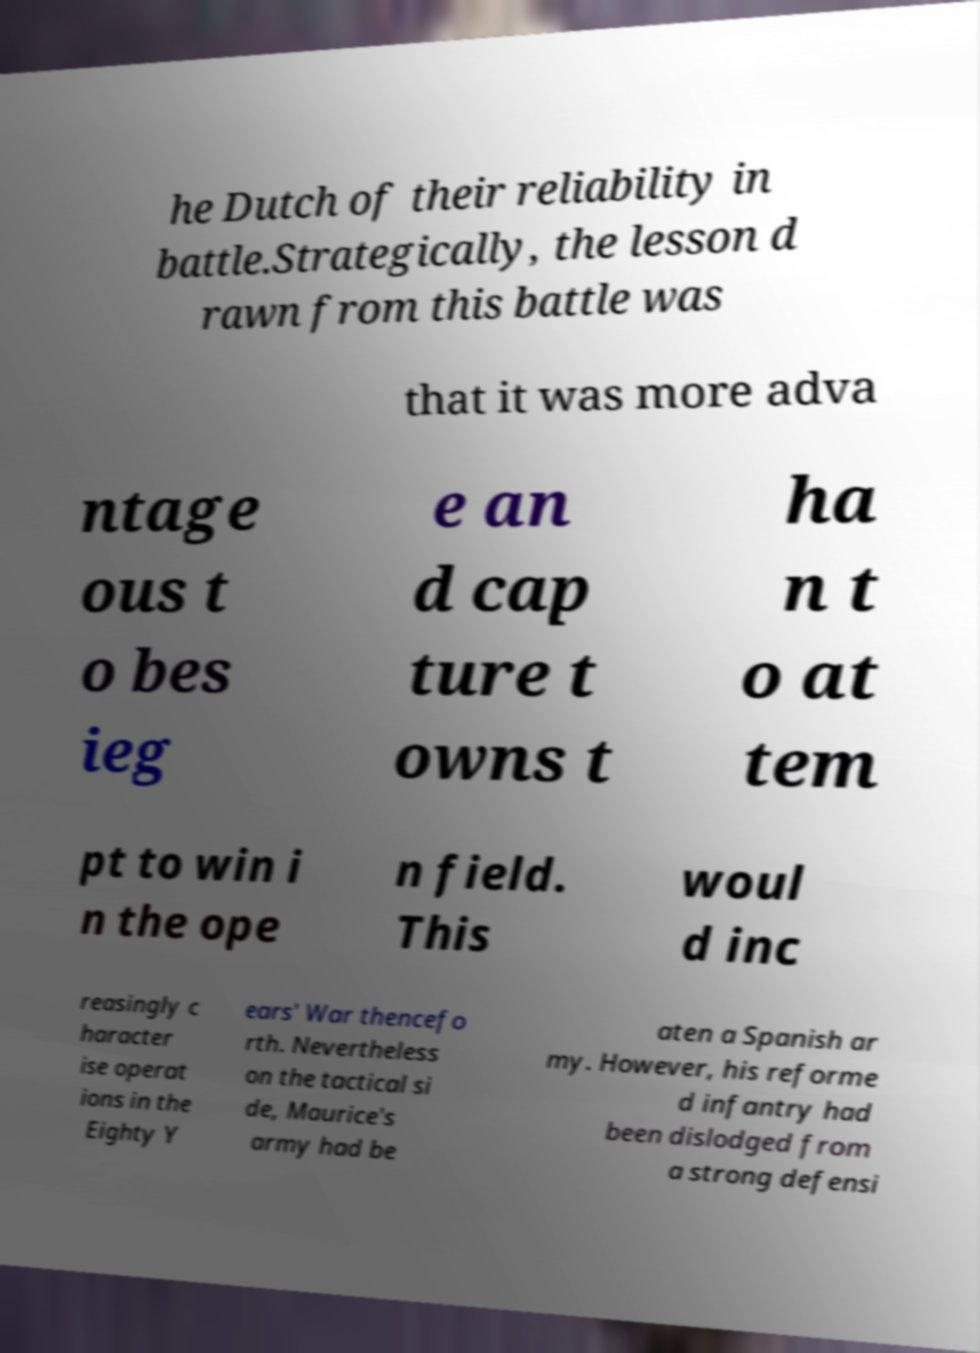Could you assist in decoding the text presented in this image and type it out clearly? he Dutch of their reliability in battle.Strategically, the lesson d rawn from this battle was that it was more adva ntage ous t o bes ieg e an d cap ture t owns t ha n t o at tem pt to win i n the ope n field. This woul d inc reasingly c haracter ise operat ions in the Eighty Y ears' War thencefo rth. Nevertheless on the tactical si de, Maurice's army had be aten a Spanish ar my. However, his reforme d infantry had been dislodged from a strong defensi 